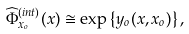Convert formula to latex. <formula><loc_0><loc_0><loc_500><loc_500>\widehat { \Phi } _ { x _ { o } } ^ { ( i n t ) } ( x ) \cong \exp \left \{ y _ { o } ( x , x _ { o } ) \right \} ,</formula> 